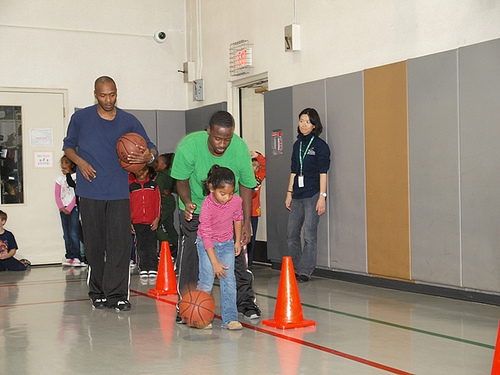<image>
Is there a man to the left of the man? Yes. From this viewpoint, the man is positioned to the left side relative to the man. Is there a girl in the school? Yes. The girl is contained within or inside the school, showing a containment relationship. 